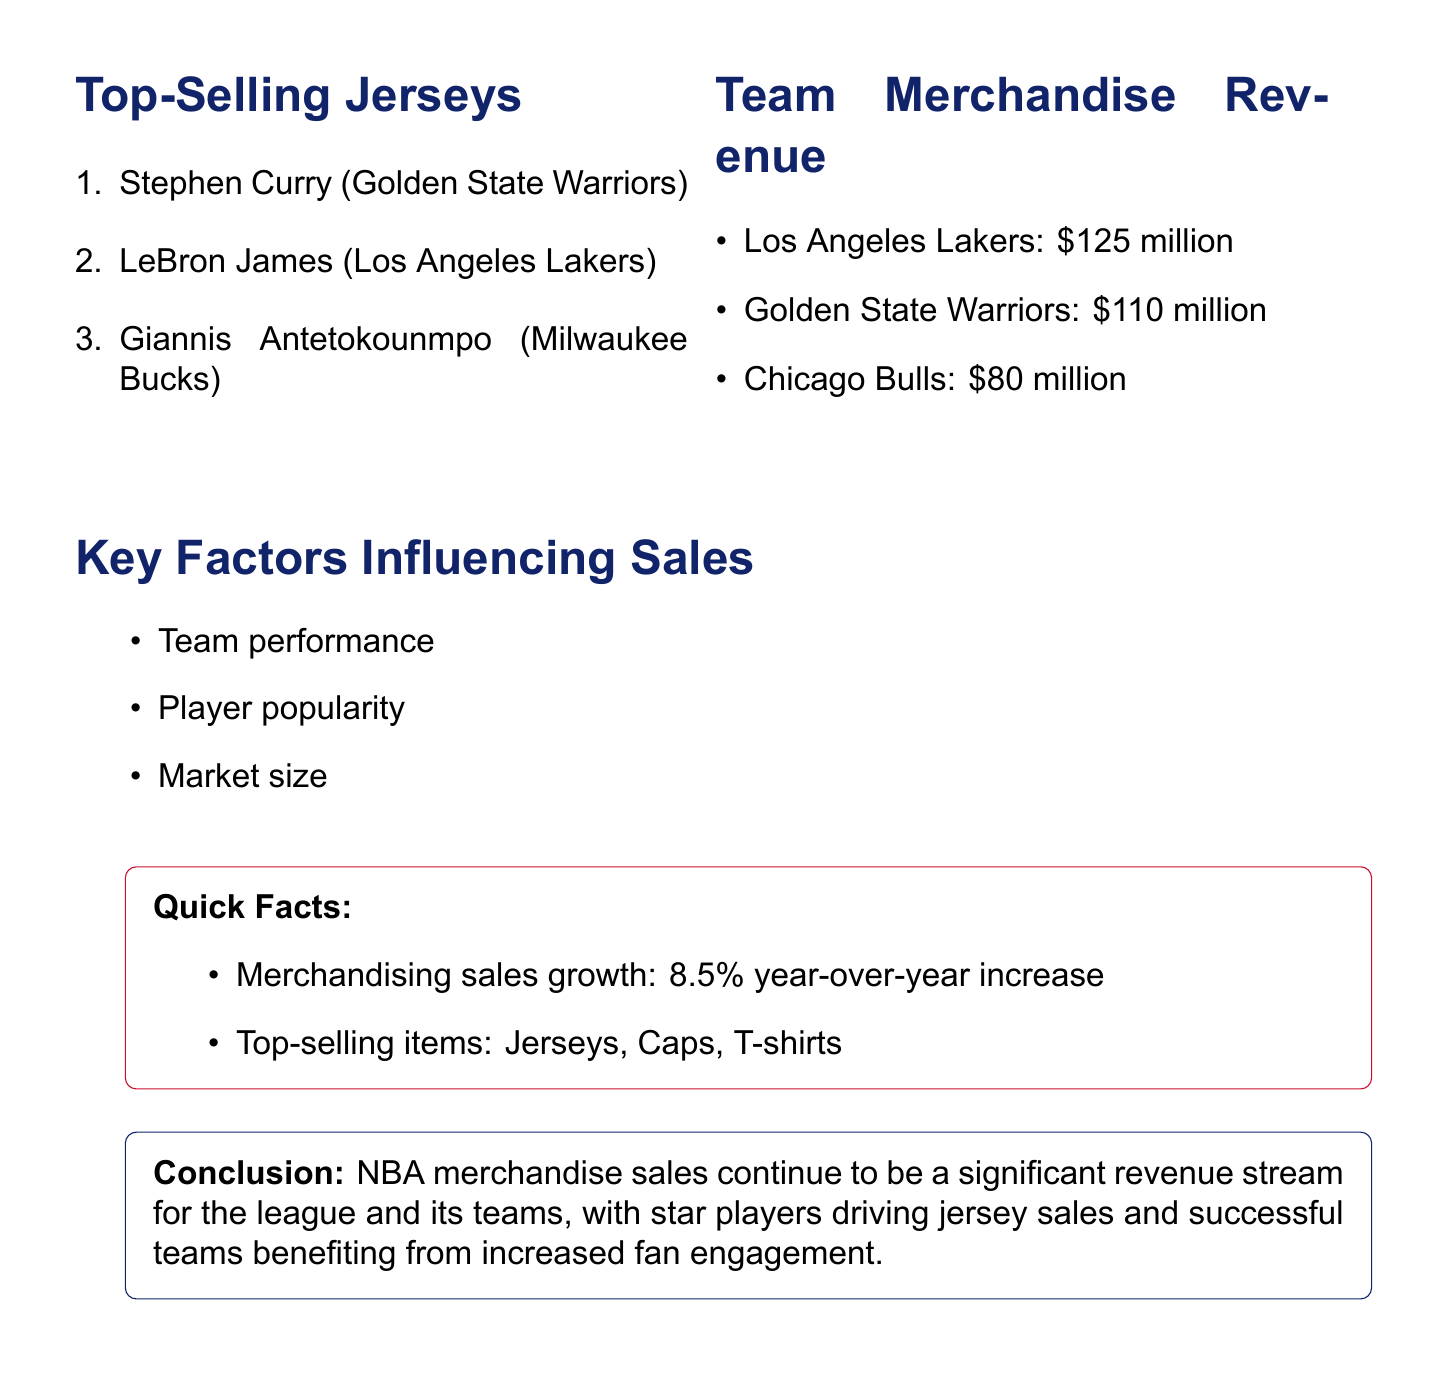What is the title of the document? The title summarizes the focus on NBA merchandising sales.
Answer: NBA Merchandising Sales Breakdown: Top-Selling Jerseys and Team Revenue Who is ranked first in top-selling jerseys? The document lists players and their ranks in terms of jersey sales.
Answer: Stephen Curry What is the revenue of the Los Angeles Lakers? The revenue amounts for each team are provided in the document.
Answer: $125 million How much did the Golden State Warriors generate in merchandise revenue? This information can be found in the team merchandise revenue section of the document.
Answer: $110 million What is the year-over-year increase in merchandising sales? The document mentions the growth of merchandising sales.
Answer: 8.5% Which item is listed as one of the top-selling items? The document lists various popular merchandise items.
Answer: Jerseys What are key factors influencing merchandise sales? The document contains a specific section listing these factors.
Answer: Team performance Which player represents the Milwaukee Bucks in the top-selling jersey list? This info can be found under the top-selling jerseys section of the document.
Answer: Giannis Antetokounmpo How much revenue did the Chicago Bulls generate in merchandise sales? The document provides specific revenue figures for different teams.
Answer: $80 million 